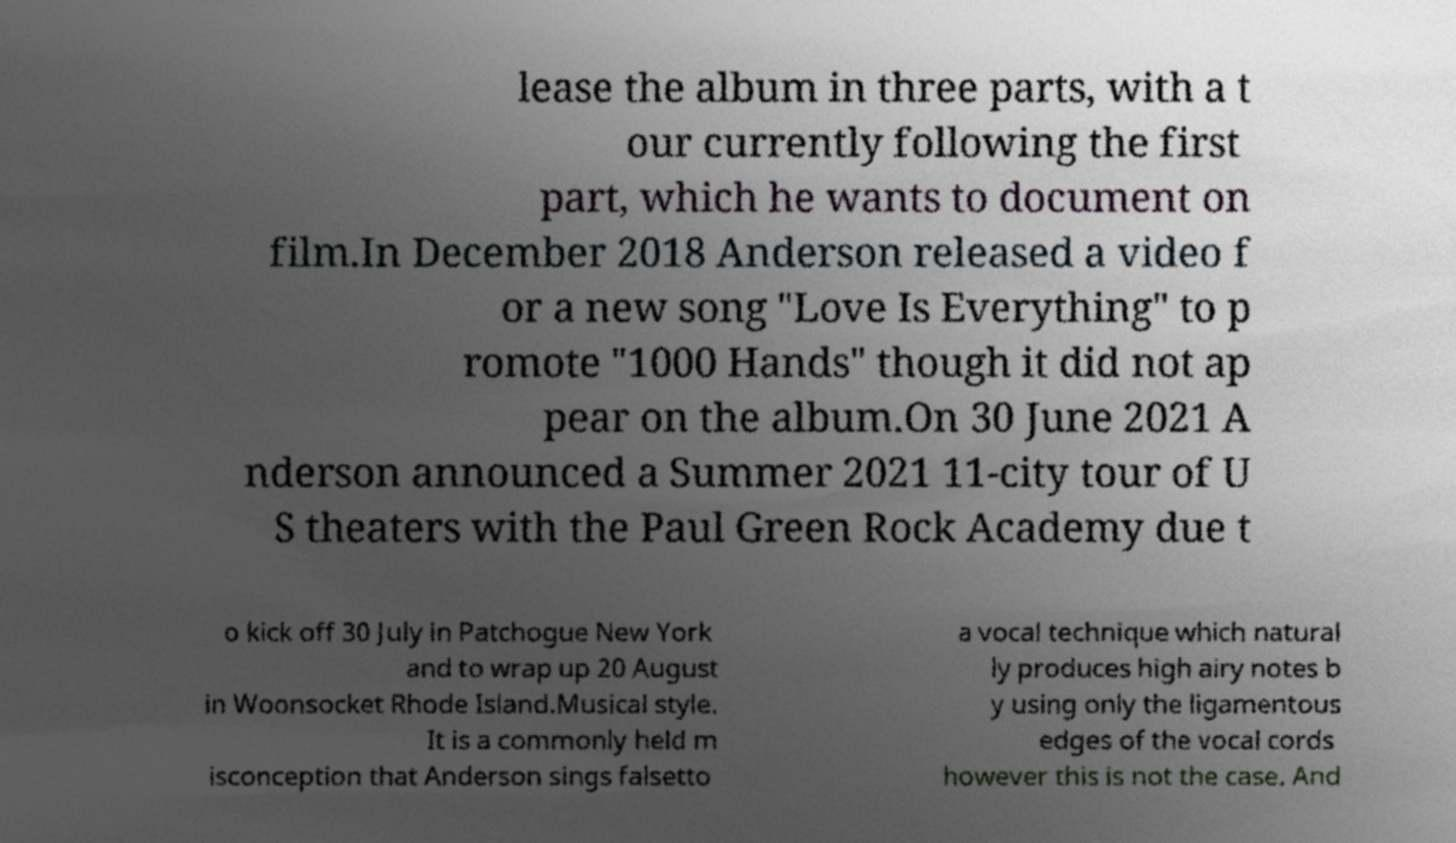Can you accurately transcribe the text from the provided image for me? lease the album in three parts, with a t our currently following the first part, which he wants to document on film.In December 2018 Anderson released a video f or a new song "Love Is Everything" to p romote "1000 Hands" though it did not ap pear on the album.On 30 June 2021 A nderson announced a Summer 2021 11-city tour of U S theaters with the Paul Green Rock Academy due t o kick off 30 July in Patchogue New York and to wrap up 20 August in Woonsocket Rhode Island.Musical style. It is a commonly held m isconception that Anderson sings falsetto a vocal technique which natural ly produces high airy notes b y using only the ligamentous edges of the vocal cords however this is not the case. And 